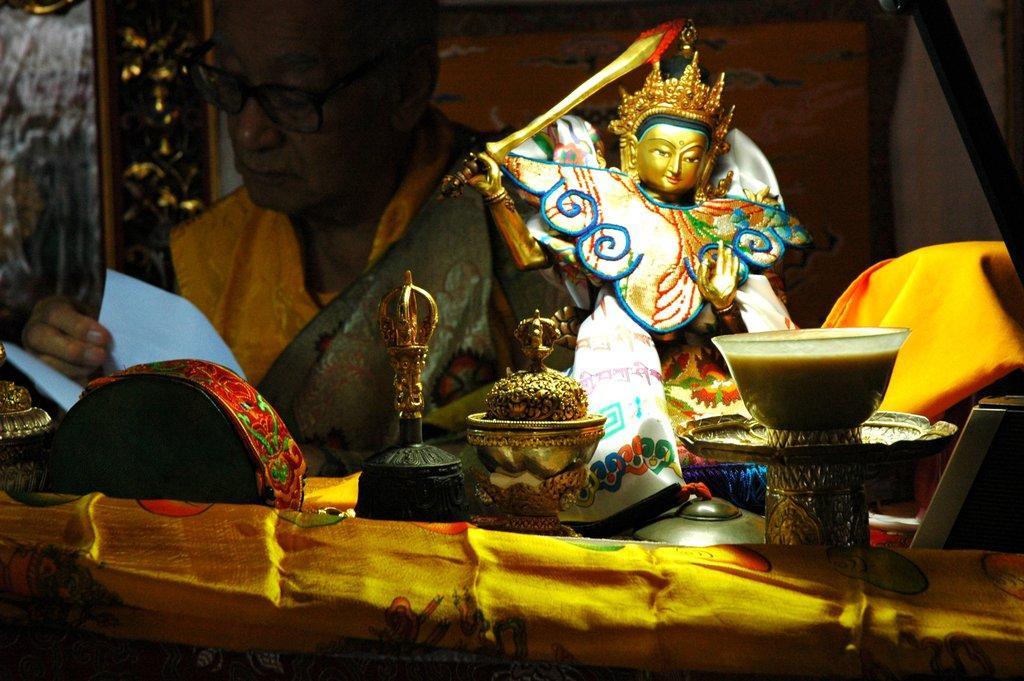Could you give a brief overview of what you see in this image? In this picture I can see a statue and few bowls and I can see a man holding some papers in his hand on the table and I can see a cloth on the table and man wore spectacles. 